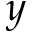<formula> <loc_0><loc_0><loc_500><loc_500>y</formula> 